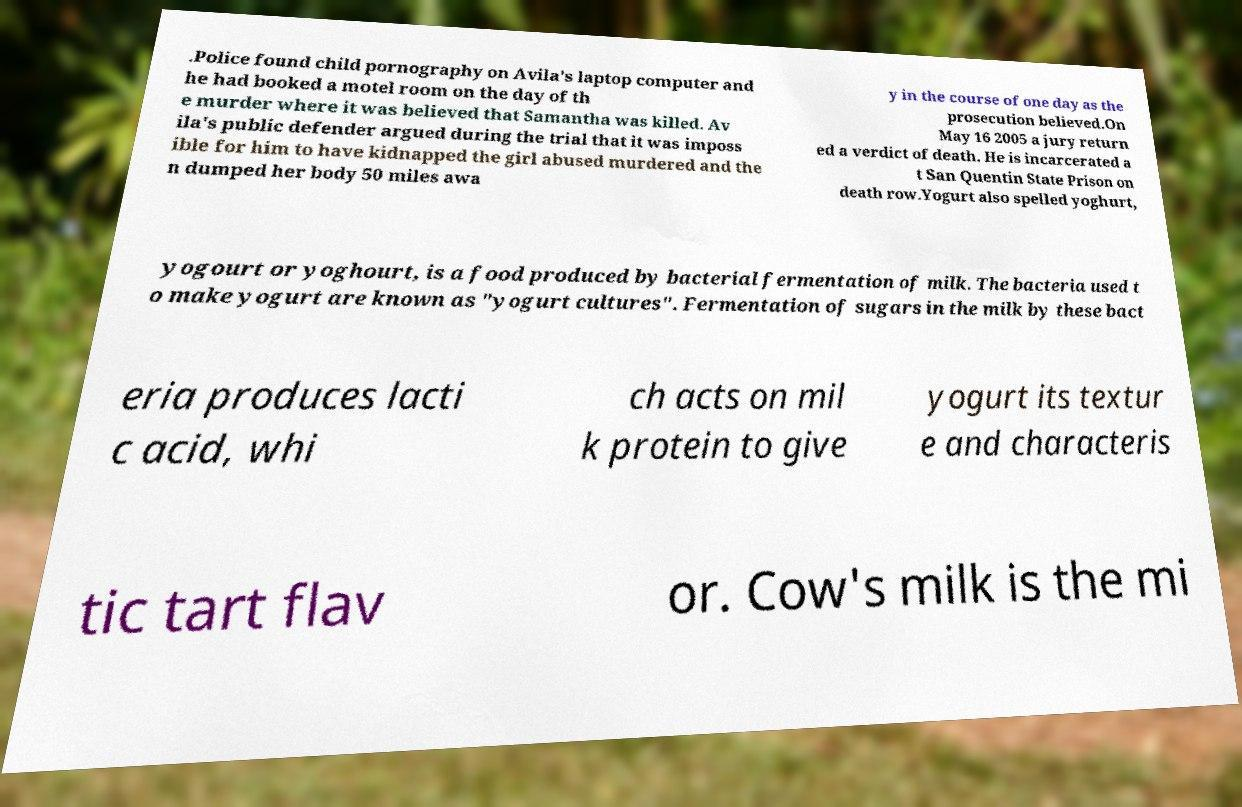Please read and relay the text visible in this image. What does it say? .Police found child pornography on Avila's laptop computer and he had booked a motel room on the day of th e murder where it was believed that Samantha was killed. Av ila's public defender argued during the trial that it was imposs ible for him to have kidnapped the girl abused murdered and the n dumped her body 50 miles awa y in the course of one day as the prosecution believed.On May 16 2005 a jury return ed a verdict of death. He is incarcerated a t San Quentin State Prison on death row.Yogurt also spelled yoghurt, yogourt or yoghourt, is a food produced by bacterial fermentation of milk. The bacteria used t o make yogurt are known as "yogurt cultures". Fermentation of sugars in the milk by these bact eria produces lacti c acid, whi ch acts on mil k protein to give yogurt its textur e and characteris tic tart flav or. Cow's milk is the mi 